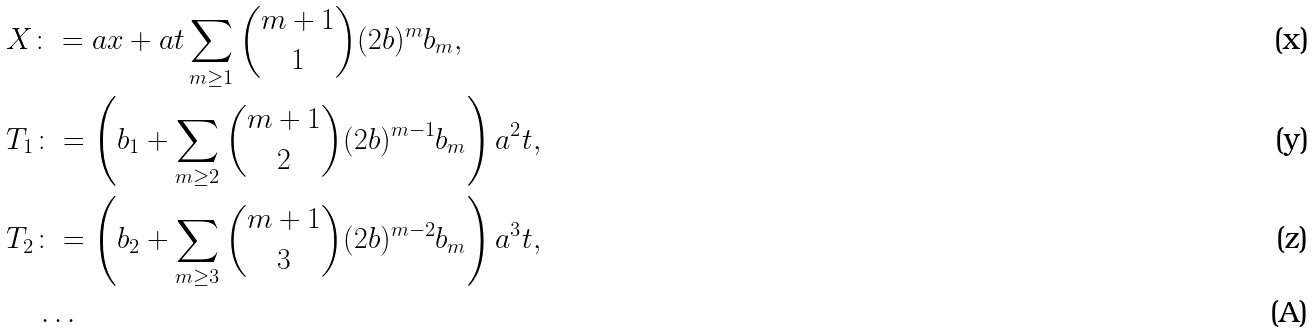<formula> <loc_0><loc_0><loc_500><loc_500>& X \colon = a x + a t \sum _ { m \geq 1 } \binom { m + 1 } { 1 } ( 2 b ) ^ { m } b _ { m } , \\ & T _ { 1 } \colon = \left ( b _ { 1 } + \sum _ { m \geq 2 } \binom { m + 1 } { 2 } ( 2 b ) ^ { m - 1 } b _ { m } \right ) a ^ { 2 } t , \\ & T _ { 2 } \colon = \left ( b _ { 2 } + \sum _ { m \geq 3 } \binom { m + 1 } { 3 } ( 2 b ) ^ { m - 2 } b _ { m } \right ) a ^ { 3 } t , \\ & \quad \dots</formula> 